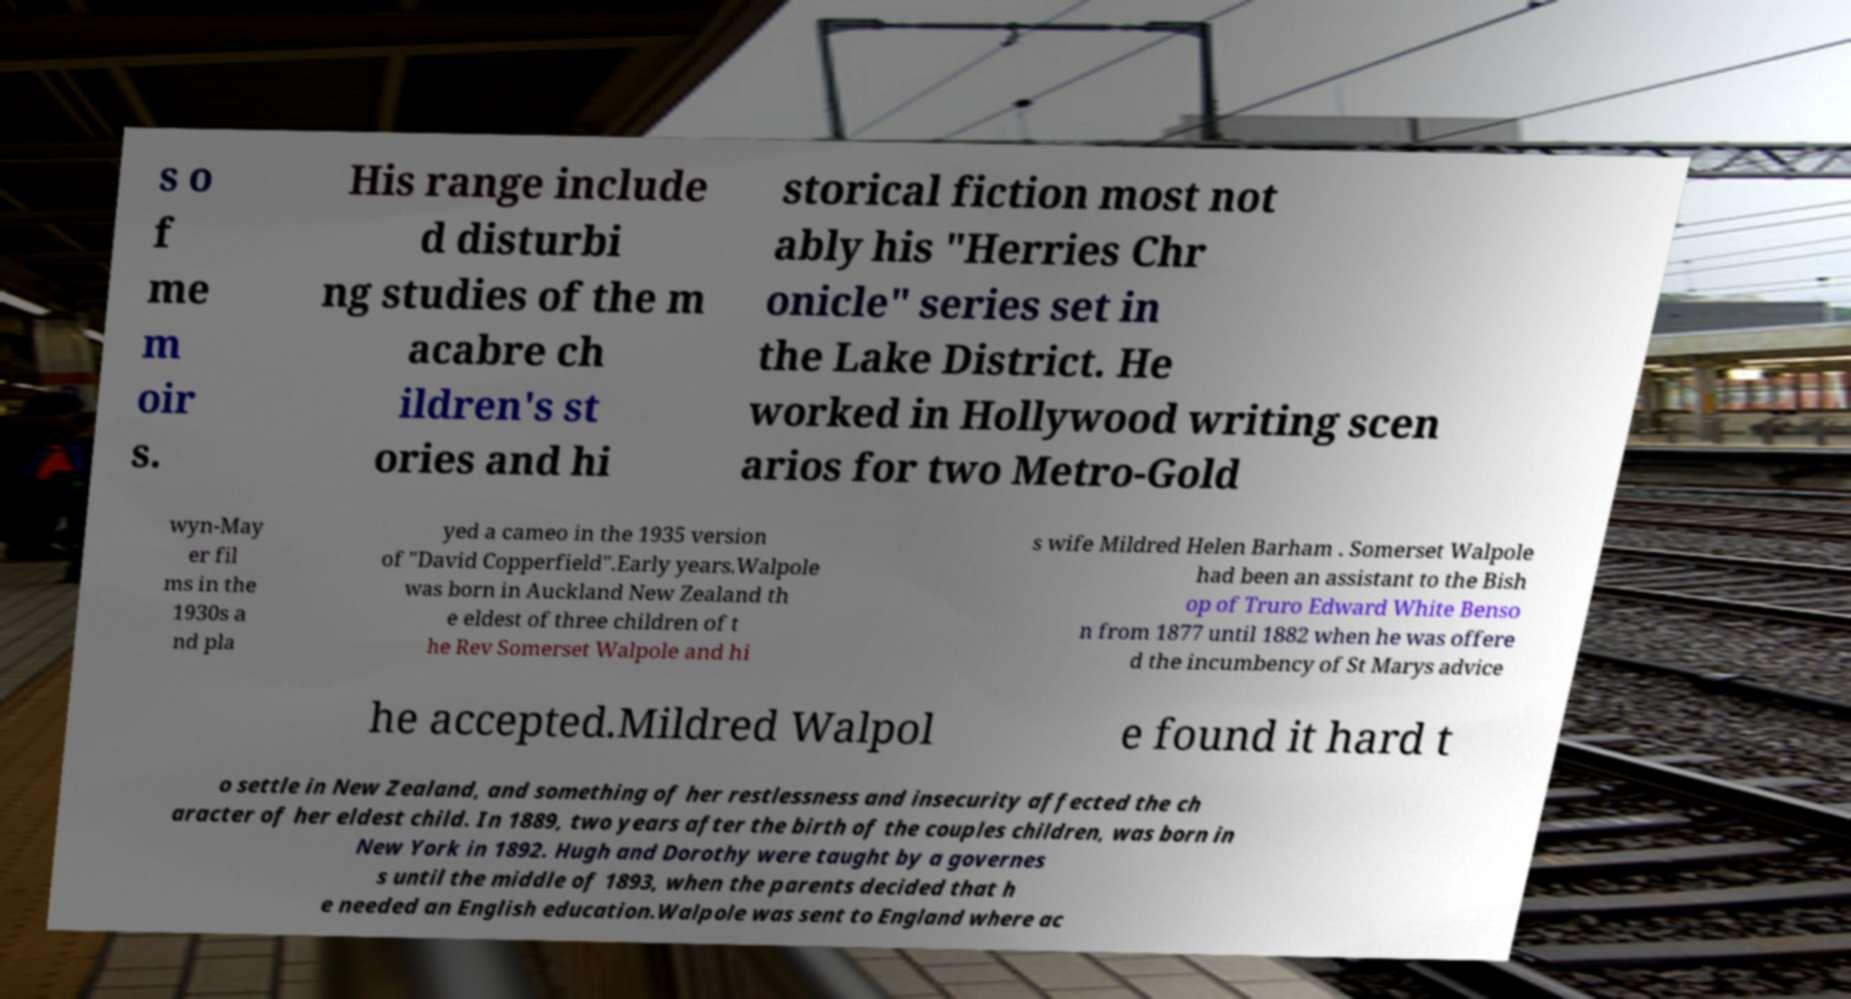Please identify and transcribe the text found in this image. s o f me m oir s. His range include d disturbi ng studies of the m acabre ch ildren's st ories and hi storical fiction most not ably his "Herries Chr onicle" series set in the Lake District. He worked in Hollywood writing scen arios for two Metro-Gold wyn-May er fil ms in the 1930s a nd pla yed a cameo in the 1935 version of "David Copperfield".Early years.Walpole was born in Auckland New Zealand th e eldest of three children of t he Rev Somerset Walpole and hi s wife Mildred Helen Barham . Somerset Walpole had been an assistant to the Bish op of Truro Edward White Benso n from 1877 until 1882 when he was offere d the incumbency of St Marys advice he accepted.Mildred Walpol e found it hard t o settle in New Zealand, and something of her restlessness and insecurity affected the ch aracter of her eldest child. In 1889, two years after the birth of the couples children, was born in New York in 1892. Hugh and Dorothy were taught by a governes s until the middle of 1893, when the parents decided that h e needed an English education.Walpole was sent to England where ac 